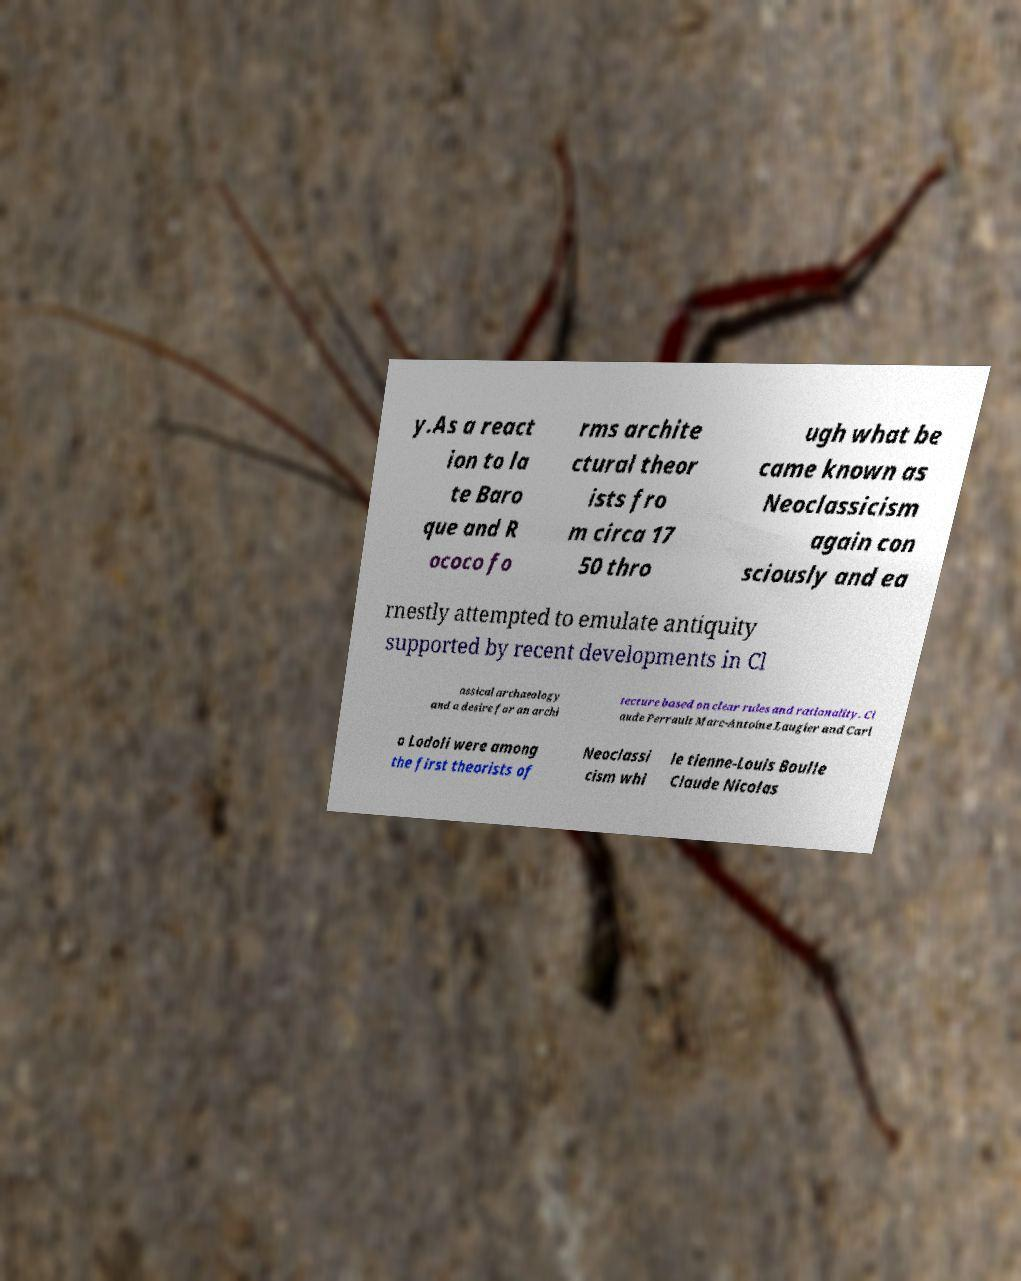I need the written content from this picture converted into text. Can you do that? y.As a react ion to la te Baro que and R ococo fo rms archite ctural theor ists fro m circa 17 50 thro ugh what be came known as Neoclassicism again con sciously and ea rnestly attempted to emulate antiquity supported by recent developments in Cl assical archaeology and a desire for an archi tecture based on clear rules and rationality. Cl aude Perrault Marc-Antoine Laugier and Carl o Lodoli were among the first theorists of Neoclassi cism whi le tienne-Louis Boulle Claude Nicolas 